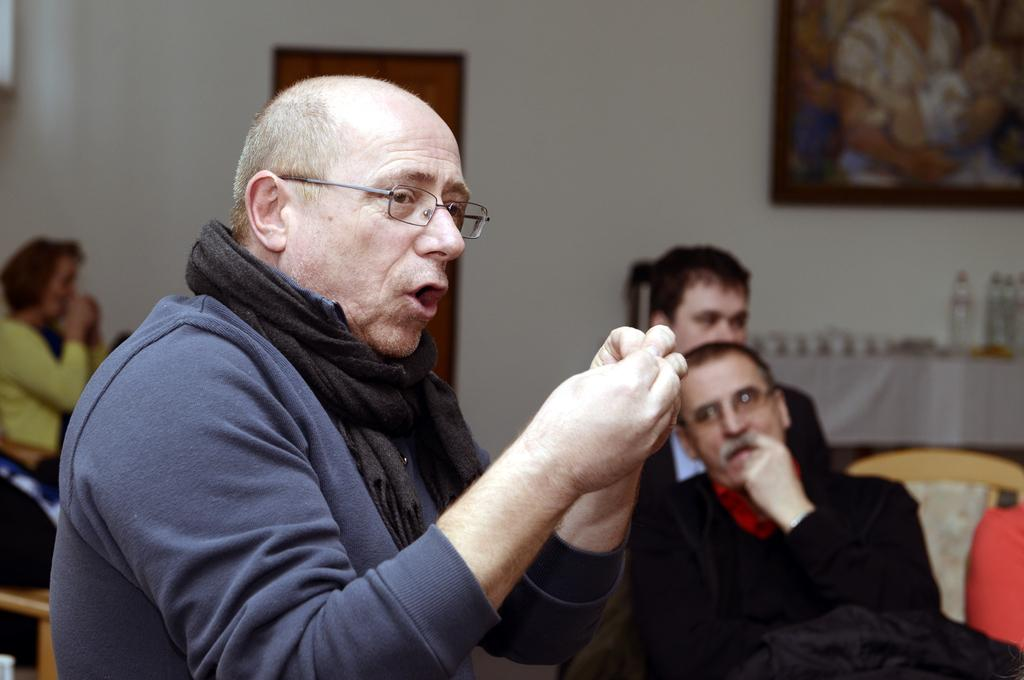What is the person in the image wearing? The person is wearing a blue and black dress in the image. What can be seen in the background of the image? There are people sitting in the background of the image. How is the frame positioned in the image? The frame is attached to the wall in the image. What type of cracker is being used as a prop in the image? There is no cracker present in the image. What type of voyage is the person in the image embarking on? The image does not depict a voyage, so it cannot be determined what type of voyage the person might be embarking on. 